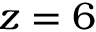Convert formula to latex. <formula><loc_0><loc_0><loc_500><loc_500>z = 6</formula> 